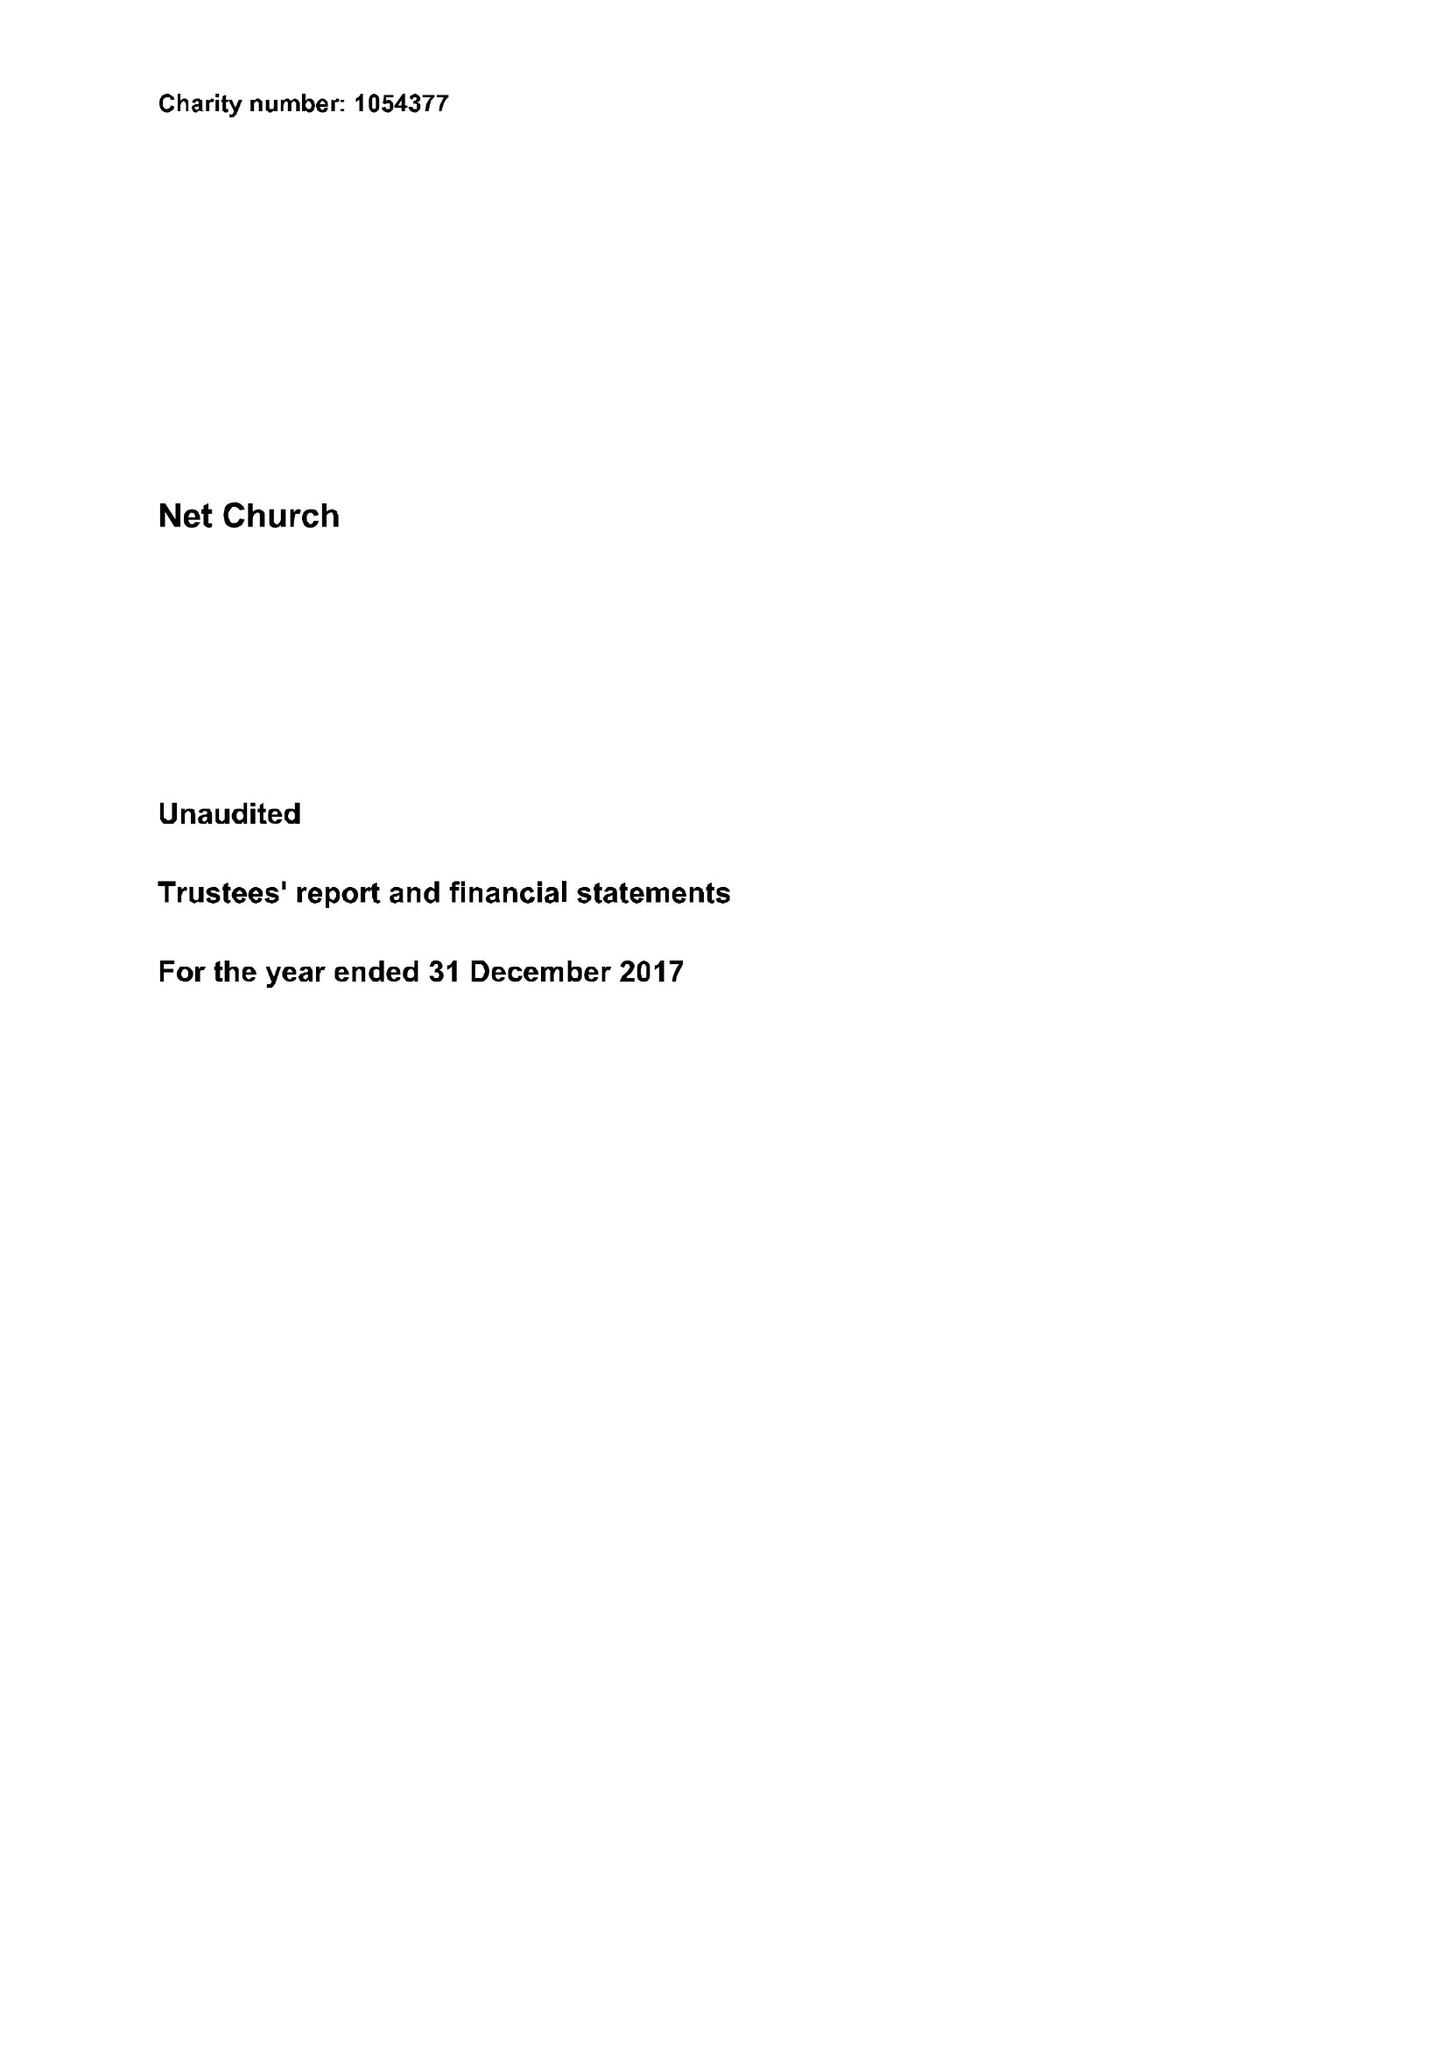What is the value for the charity_number?
Answer the question using a single word or phrase. 1054377 